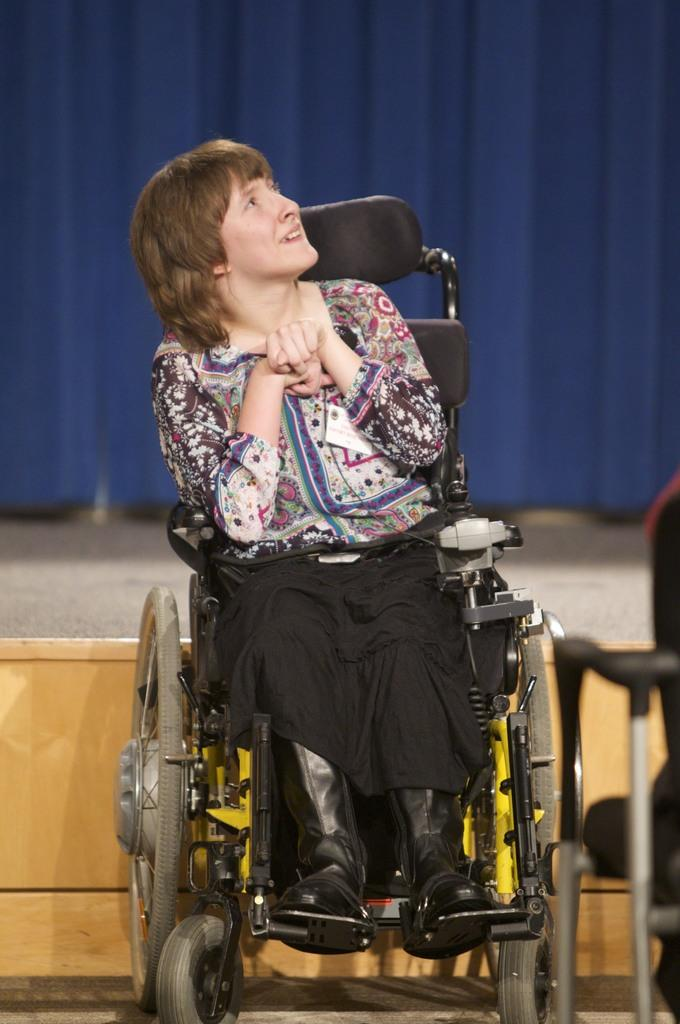What is the woman in the image sitting on? The woman is sitting on a wheelchair in the image. What can be seen in the background of the image? There is a stage and a blue curtain in the background of the image. What is located on the right side of the image? There is a chair on the right side of the image. What type of feather can be seen on the chicken in the image? There is no feather or chicken present in the image. 